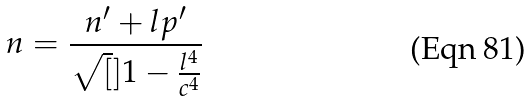Convert formula to latex. <formula><loc_0><loc_0><loc_500><loc_500>n = \frac { n ^ { \prime } + l p ^ { \prime } } { \sqrt { [ } ] { 1 - \frac { l ^ { 4 } } { c ^ { 4 } } } }</formula> 